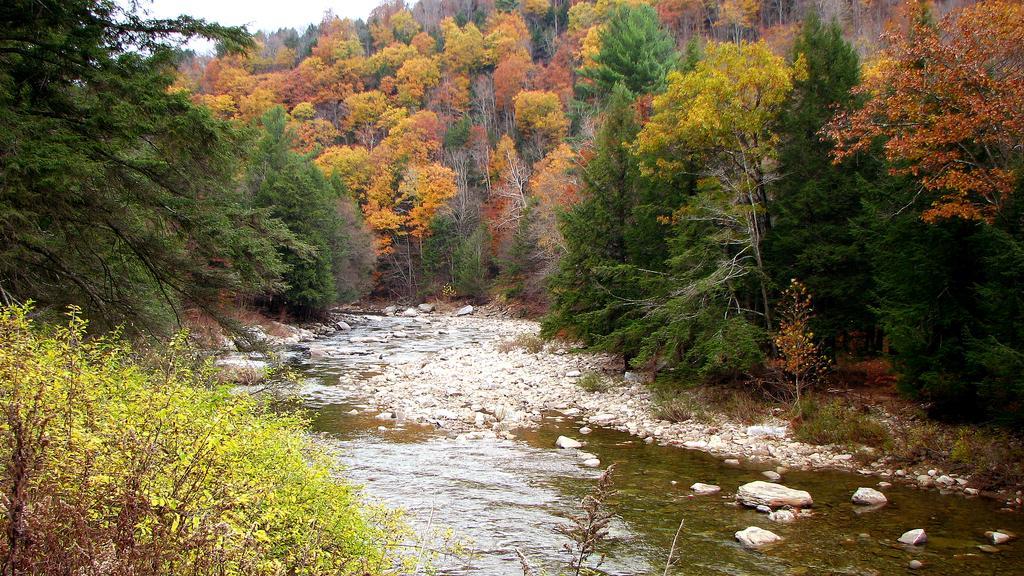How would you summarize this image in a sentence or two? In this image we can see a lake and some rocks in it. In the background we can see group of trees and sky. 